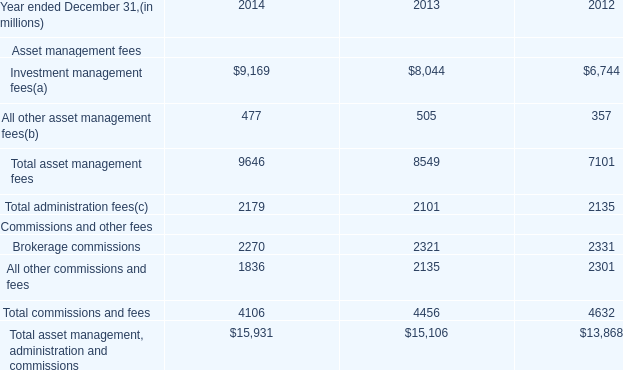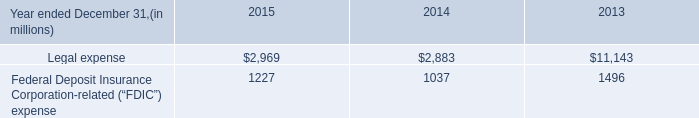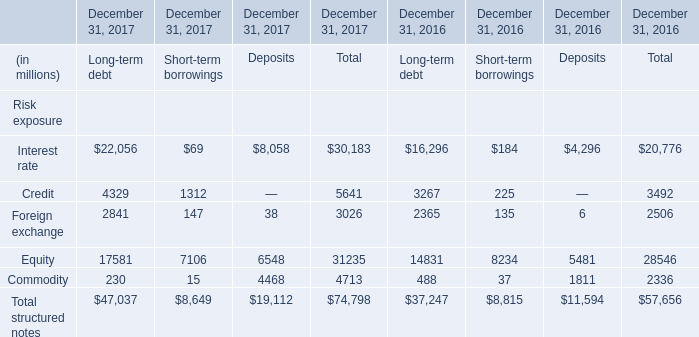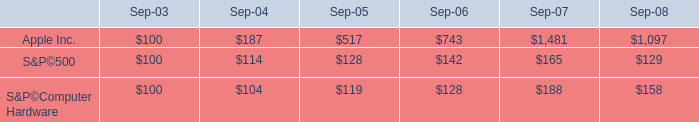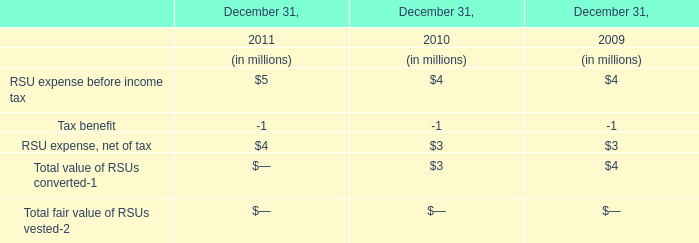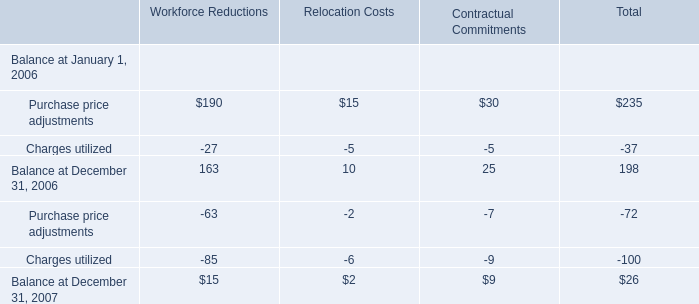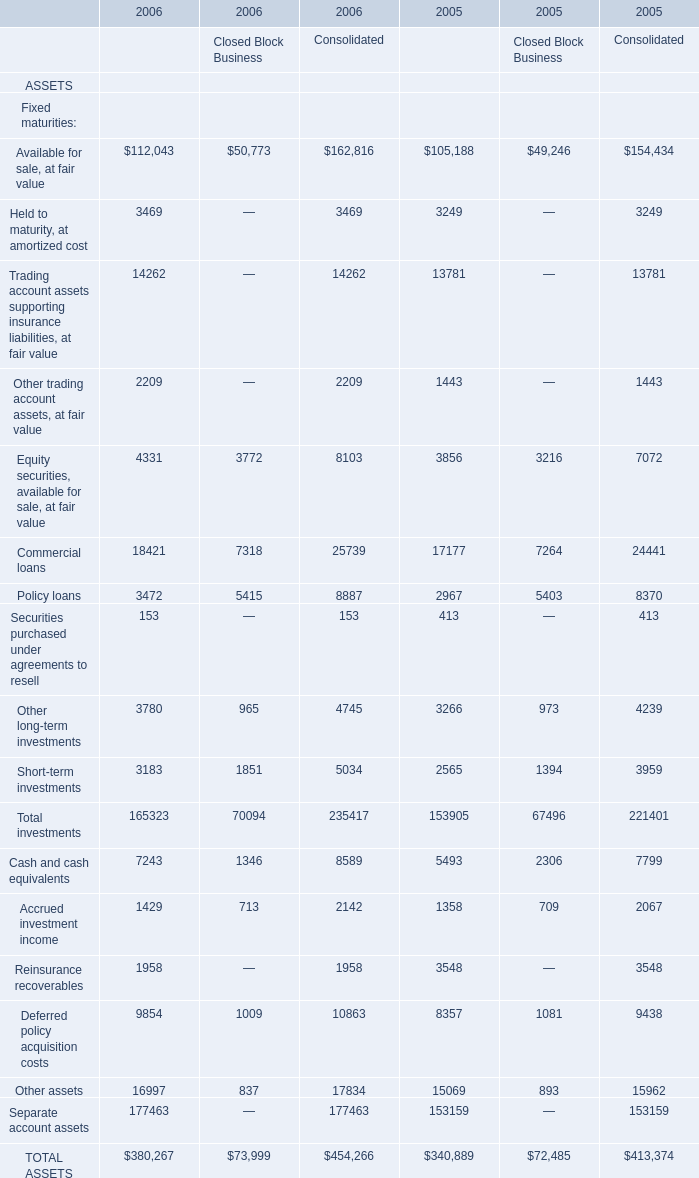What is the sum of the TOTAL ASSETS in the years where Available for sale, at fair value greater than 0? 
Computations: (((((380267 + 73999) + 454266) + 340889) + 72485) + 413374)
Answer: 1735280.0. 